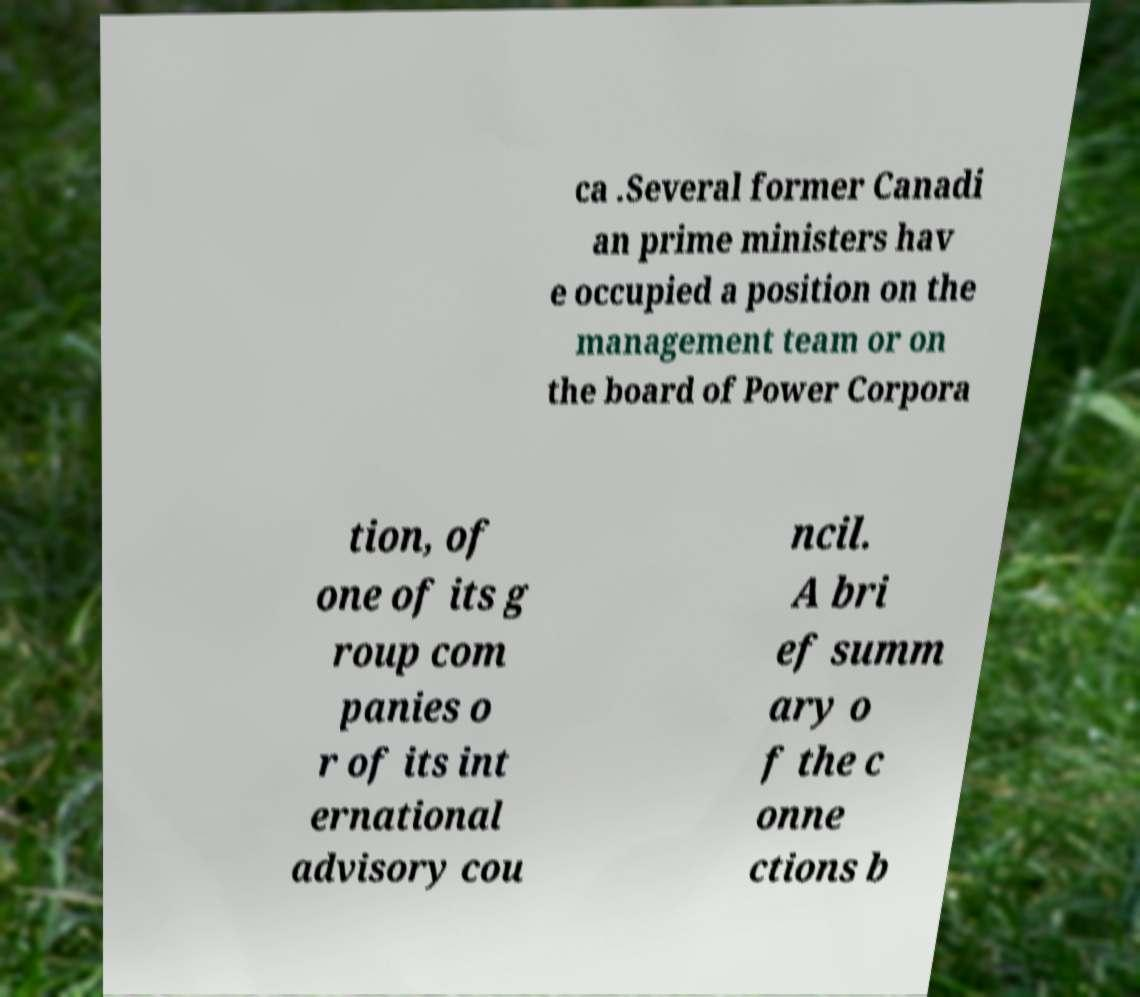Please identify and transcribe the text found in this image. ca .Several former Canadi an prime ministers hav e occupied a position on the management team or on the board of Power Corpora tion, of one of its g roup com panies o r of its int ernational advisory cou ncil. A bri ef summ ary o f the c onne ctions b 